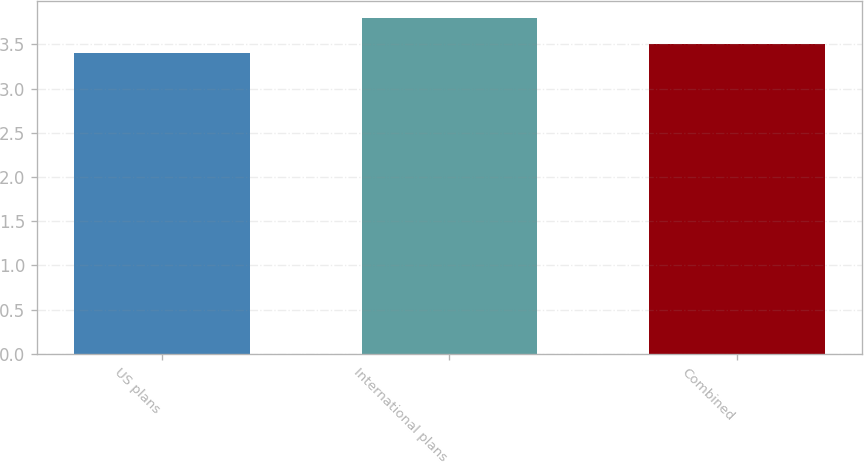<chart> <loc_0><loc_0><loc_500><loc_500><bar_chart><fcel>US plans<fcel>International plans<fcel>Combined<nl><fcel>3.4<fcel>3.8<fcel>3.5<nl></chart> 